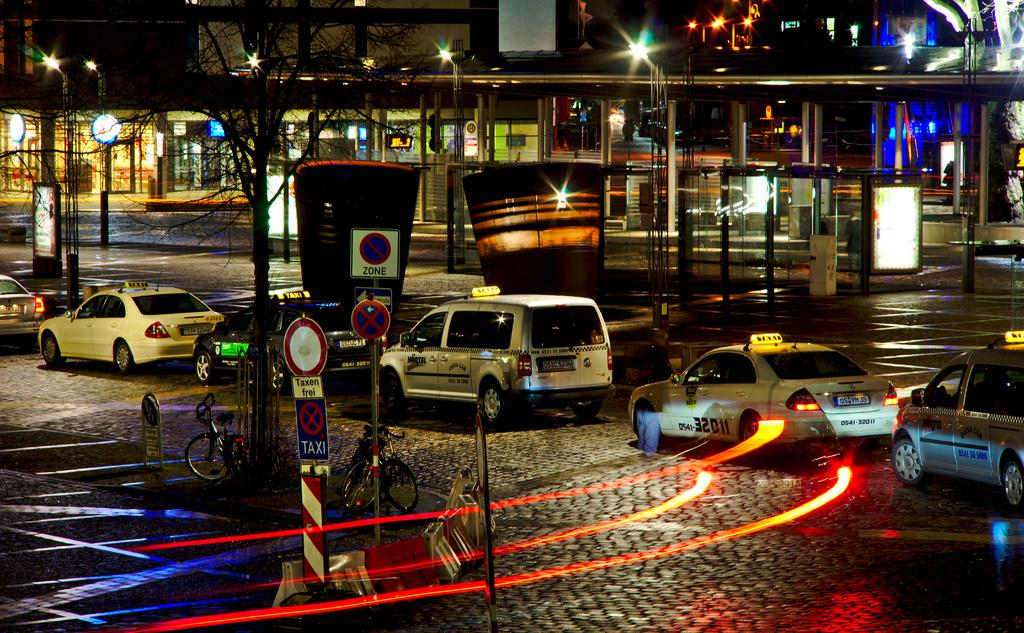What can be seen on the road in the image? There are vehicles on the road in the image. What structures are present in the image? There are poles, sign boards, a tree, bicycles, rods on a platform, pillars, and a shed in the image. What is the purpose of the sign boards in the image? The sign boards in the image are likely used for providing information or directions to people. What can be seen in the background of the image? In the background of the image, there are pillars, a shed, and lights. Can you tell me how many geese are depicted on the sign boards in the image? There are no geese depicted on the sign boards in the image. What type of control is being exerted by the rods on the platform in the image? There is no control being exerted by the rods on the platform in the image; they are simply objects on a platform. 